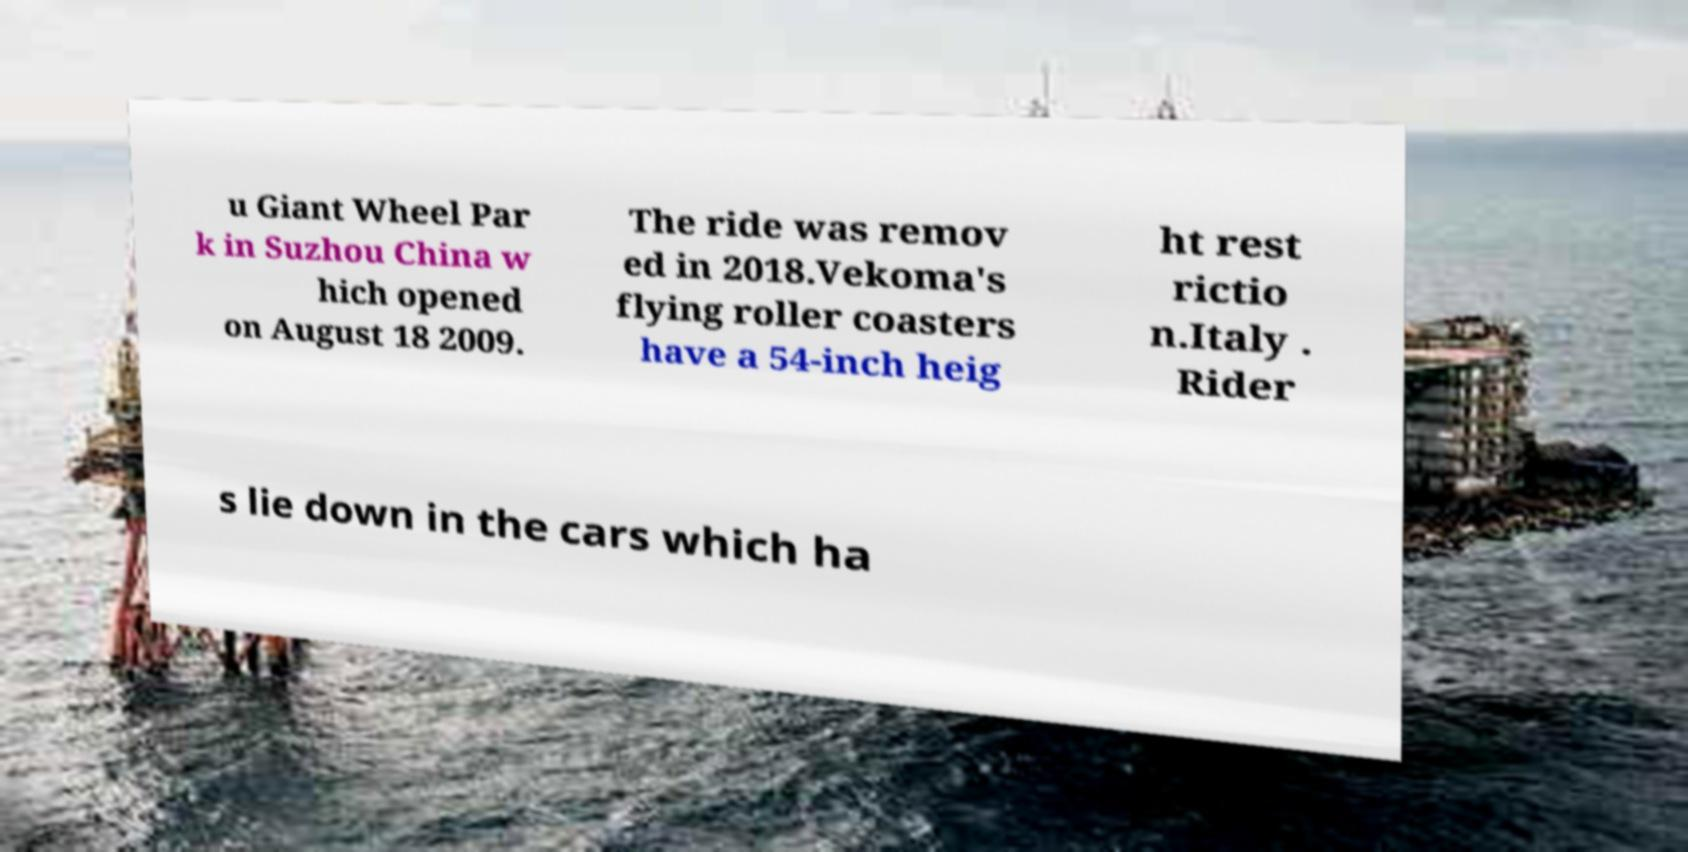What messages or text are displayed in this image? I need them in a readable, typed format. u Giant Wheel Par k in Suzhou China w hich opened on August 18 2009. The ride was remov ed in 2018.Vekoma's flying roller coasters have a 54-inch heig ht rest rictio n.Italy . Rider s lie down in the cars which ha 